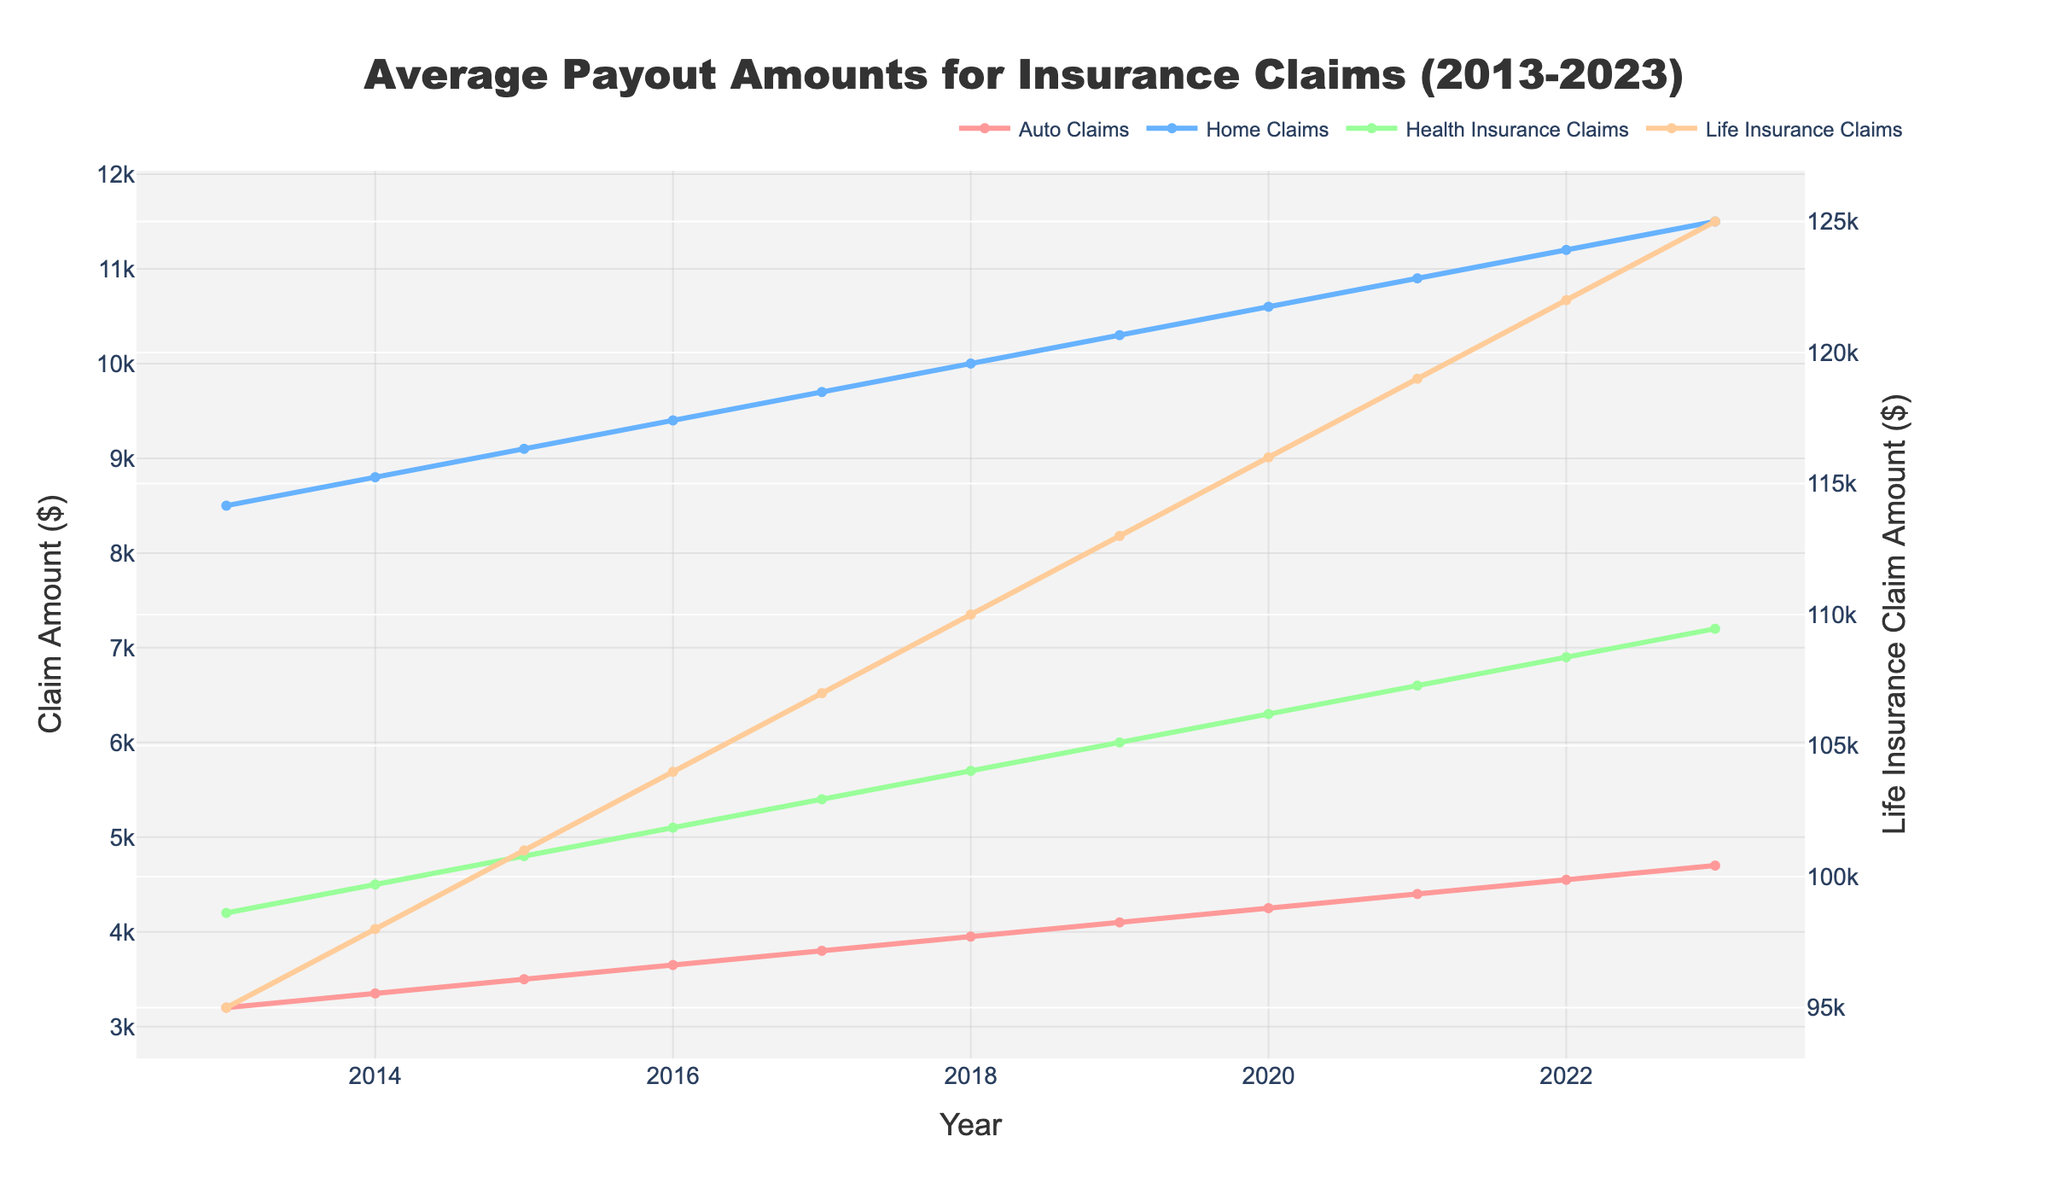Which type of insurance claim had the highest average payout amount in 2015? The figure shows the trends for different types of claims. Observing 2015, we see that Life Insurance Claims had the highest amount, indicated by the highest point on the yellow line.
Answer: Life Insurance Claims How did the average payout amount for Health Insurance Claims change from 2017 to 2020? To determine the change, compare the values for 2017 and 2020: 5400 in 2017 and 6300 in 2020. Subtract the 2017 value from the 2020 value: 6300 - 5400 = 900.
Answer: Increased by 900 Between 2013 and 2023, which type of claim shows the smallest increase in average payout amount? Calculate the increase for each type: Auto Claims (4700 - 3200), Home Claims (11500 - 8500), Life Insurance Claims (125000 - 95000), and Health Insurance Claims (7200 - 4200). The smallest increase is for Health Insurance Claims: 7200 - 4200 = 3000.
Answer: Health Insurance Claims What was the average payout amount for Home Claims in 2022? Look at the point corresponding to Home Claims in 2022. The value is at the light blue marker for 2022, which reads 11200.
Answer: 11200 By how much did the Life Insurance Claim average payout amount increase from 2016 to 2023? Calculate the difference between 2023 and 2016 Life Insurance Claims amounts: 125000 - 104000 = 21000.
Answer: 21000 Which two types of claims have the same visual trend with consistent upward direction? By observing the visual trends, Auto Claims (red) and Home Claims (light blue) both have continuously upward trends without any declines.
Answer: Auto Claims and Home Claims In which year did Health Insurance Claims reach a payout amount of 5100? Find the point on the green line that corresponds to 5100. The plot indicates this amount in the year 2016.
Answer: 2016 How much did Auto Claims increase by from 2019 to 2021? Look at the figures for Auto Claims in 2019 and 2021: 4400 - 4100 = 300.
Answer: 300 Among the four types of claims, which one had the highest rate of increase from 2013 to 2023? Calculate the rate of increase: divide the difference by the initial amount for each type: Auto Claims (4700-3200)/3200, Home Claims (11500-8500)/8500, Life Insurance Claims (125000-95000)/95000, Health Insurance Claims (7200-4200)/4200. The highest rate of increase is for Auto Claims: (4700-3200)/3200 ≈ 0.47 (47%).
Answer: Auto Claims To which year does the highest point on the green line belong? The highest point on the green line (Health Insurance Claims) is in 2023, located at height 7200.
Answer: 2023 